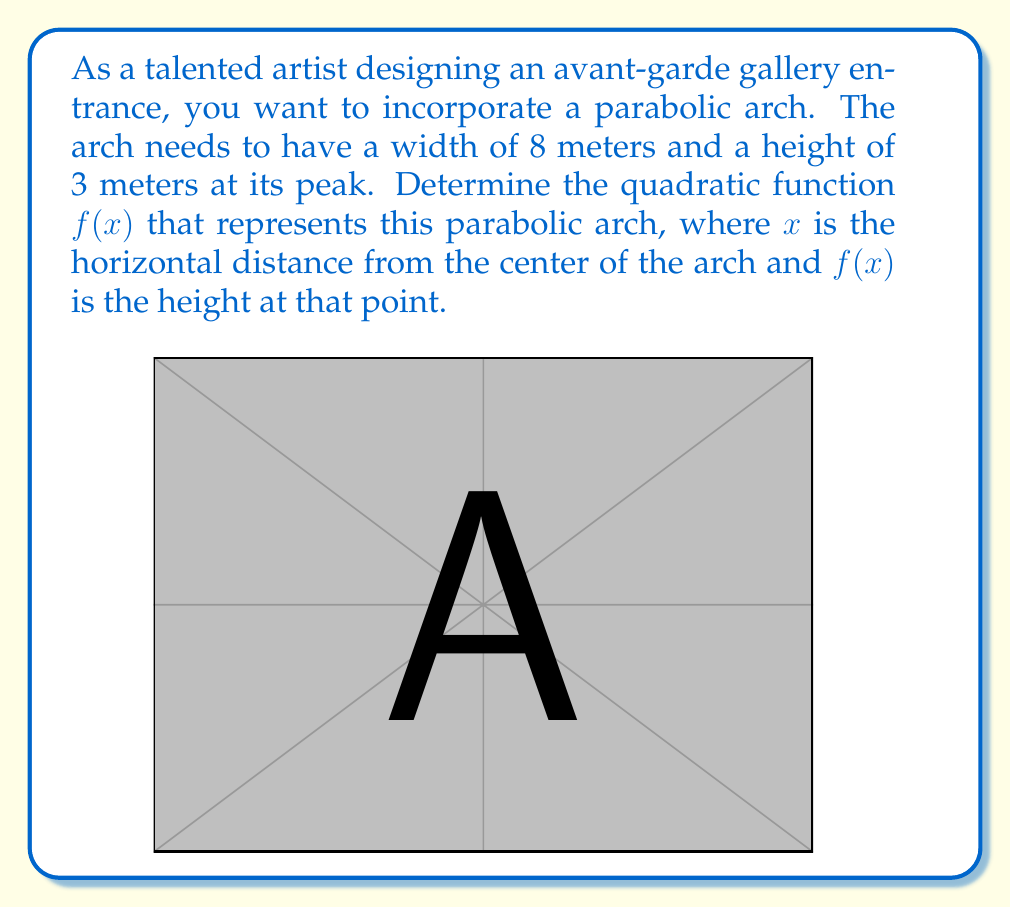Help me with this question. Let's approach this step-by-step:

1) The general form of a quadratic function is $f(x) = ax^2 + bx + c$.

2) Since the arch is symmetrical, the axis of symmetry is at $x = 0$. This means there's no $x$ term, so $b = 0$.

3) Our function becomes $f(x) = ax^2 + c$.

4) We know two points on this parabola:
   - At the peak: $(0, 3)$
   - At the edge: $(4, 0)$ (since the width is 8 meters, half of that is 4 meters)

5) Let's use the peak point first: $f(0) = 3$
   $3 = a(0)^2 + c$
   $c = 3$

6) Now our function is $f(x) = ax^2 + 3$

7) Let's use the edge point: $f(4) = 0$
   $0 = a(4)^2 + 3$
   $-3 = 16a$
   $a = -\frac{3}{16}$

8) Therefore, our final function is:

   $f(x) = -\frac{3}{16}x^2 + 3$

This function represents a parabola that opens downward, has its vertex at (0, 3), and passes through the points (-4, 0) and (4, 0), creating an arch with the desired dimensions.
Answer: $f(x) = -\frac{3}{16}x^2 + 3$ 